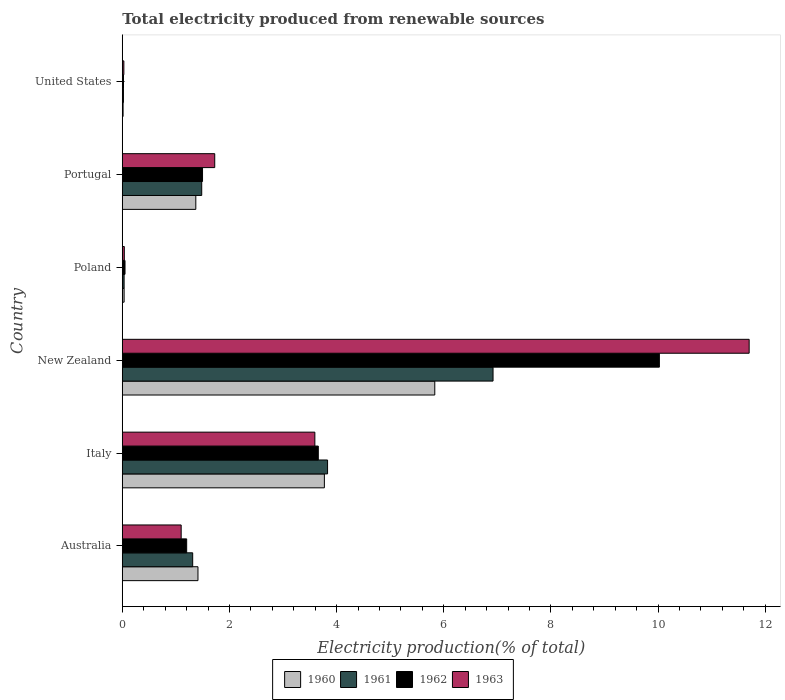How many different coloured bars are there?
Provide a succinct answer. 4. How many groups of bars are there?
Your answer should be very brief. 6. Are the number of bars per tick equal to the number of legend labels?
Provide a short and direct response. Yes. Are the number of bars on each tick of the Y-axis equal?
Give a very brief answer. Yes. How many bars are there on the 1st tick from the bottom?
Give a very brief answer. 4. What is the label of the 5th group of bars from the top?
Offer a very short reply. Italy. In how many cases, is the number of bars for a given country not equal to the number of legend labels?
Make the answer very short. 0. What is the total electricity produced in 1960 in Australia?
Make the answer very short. 1.41. Across all countries, what is the maximum total electricity produced in 1962?
Provide a short and direct response. 10.02. Across all countries, what is the minimum total electricity produced in 1960?
Provide a succinct answer. 0.02. In which country was the total electricity produced in 1963 maximum?
Provide a succinct answer. New Zealand. What is the total total electricity produced in 1961 in the graph?
Make the answer very short. 13.6. What is the difference between the total electricity produced in 1963 in Italy and that in Poland?
Make the answer very short. 3.56. What is the difference between the total electricity produced in 1961 in Australia and the total electricity produced in 1963 in Portugal?
Your answer should be compact. -0.41. What is the average total electricity produced in 1962 per country?
Ensure brevity in your answer.  2.74. What is the difference between the total electricity produced in 1963 and total electricity produced in 1962 in New Zealand?
Make the answer very short. 1.68. What is the ratio of the total electricity produced in 1961 in Portugal to that in United States?
Your answer should be compact. 68.83. What is the difference between the highest and the second highest total electricity produced in 1960?
Give a very brief answer. 2.06. What is the difference between the highest and the lowest total electricity produced in 1963?
Your answer should be very brief. 11.67. In how many countries, is the total electricity produced in 1962 greater than the average total electricity produced in 1962 taken over all countries?
Offer a terse response. 2. Is the sum of the total electricity produced in 1961 in Italy and United States greater than the maximum total electricity produced in 1962 across all countries?
Offer a terse response. No. Is it the case that in every country, the sum of the total electricity produced in 1961 and total electricity produced in 1962 is greater than the sum of total electricity produced in 1960 and total electricity produced in 1963?
Make the answer very short. No. How many bars are there?
Provide a succinct answer. 24. Are all the bars in the graph horizontal?
Provide a short and direct response. Yes. How many countries are there in the graph?
Ensure brevity in your answer.  6. What is the difference between two consecutive major ticks on the X-axis?
Your response must be concise. 2. Are the values on the major ticks of X-axis written in scientific E-notation?
Give a very brief answer. No. Does the graph contain any zero values?
Make the answer very short. No. Where does the legend appear in the graph?
Your answer should be very brief. Bottom center. How are the legend labels stacked?
Your response must be concise. Horizontal. What is the title of the graph?
Your answer should be very brief. Total electricity produced from renewable sources. What is the label or title of the X-axis?
Your answer should be very brief. Electricity production(% of total). What is the Electricity production(% of total) in 1960 in Australia?
Your answer should be very brief. 1.41. What is the Electricity production(% of total) of 1961 in Australia?
Your answer should be compact. 1.31. What is the Electricity production(% of total) of 1962 in Australia?
Keep it short and to the point. 1.2. What is the Electricity production(% of total) of 1963 in Australia?
Your response must be concise. 1.1. What is the Electricity production(% of total) in 1960 in Italy?
Keep it short and to the point. 3.77. What is the Electricity production(% of total) of 1961 in Italy?
Your answer should be very brief. 3.83. What is the Electricity production(% of total) of 1962 in Italy?
Your answer should be compact. 3.66. What is the Electricity production(% of total) of 1963 in Italy?
Ensure brevity in your answer.  3.59. What is the Electricity production(% of total) of 1960 in New Zealand?
Your answer should be very brief. 5.83. What is the Electricity production(% of total) of 1961 in New Zealand?
Offer a terse response. 6.92. What is the Electricity production(% of total) of 1962 in New Zealand?
Keep it short and to the point. 10.02. What is the Electricity production(% of total) of 1963 in New Zealand?
Make the answer very short. 11.7. What is the Electricity production(% of total) of 1960 in Poland?
Your response must be concise. 0.03. What is the Electricity production(% of total) of 1961 in Poland?
Offer a terse response. 0.03. What is the Electricity production(% of total) of 1962 in Poland?
Make the answer very short. 0.05. What is the Electricity production(% of total) in 1963 in Poland?
Give a very brief answer. 0.04. What is the Electricity production(% of total) in 1960 in Portugal?
Your response must be concise. 1.37. What is the Electricity production(% of total) in 1961 in Portugal?
Your answer should be compact. 1.48. What is the Electricity production(% of total) of 1962 in Portugal?
Provide a succinct answer. 1.5. What is the Electricity production(% of total) of 1963 in Portugal?
Provide a succinct answer. 1.73. What is the Electricity production(% of total) in 1960 in United States?
Give a very brief answer. 0.02. What is the Electricity production(% of total) of 1961 in United States?
Keep it short and to the point. 0.02. What is the Electricity production(% of total) of 1962 in United States?
Your response must be concise. 0.02. What is the Electricity production(% of total) in 1963 in United States?
Your answer should be compact. 0.03. Across all countries, what is the maximum Electricity production(% of total) in 1960?
Ensure brevity in your answer.  5.83. Across all countries, what is the maximum Electricity production(% of total) in 1961?
Your response must be concise. 6.92. Across all countries, what is the maximum Electricity production(% of total) of 1962?
Provide a short and direct response. 10.02. Across all countries, what is the maximum Electricity production(% of total) in 1963?
Your answer should be very brief. 11.7. Across all countries, what is the minimum Electricity production(% of total) of 1960?
Give a very brief answer. 0.02. Across all countries, what is the minimum Electricity production(% of total) in 1961?
Keep it short and to the point. 0.02. Across all countries, what is the minimum Electricity production(% of total) of 1962?
Ensure brevity in your answer.  0.02. Across all countries, what is the minimum Electricity production(% of total) of 1963?
Provide a short and direct response. 0.03. What is the total Electricity production(% of total) in 1960 in the graph?
Provide a short and direct response. 12.44. What is the total Electricity production(% of total) in 1961 in the graph?
Ensure brevity in your answer.  13.6. What is the total Electricity production(% of total) in 1962 in the graph?
Your answer should be compact. 16.46. What is the total Electricity production(% of total) in 1963 in the graph?
Your response must be concise. 18.19. What is the difference between the Electricity production(% of total) of 1960 in Australia and that in Italy?
Your answer should be very brief. -2.36. What is the difference between the Electricity production(% of total) of 1961 in Australia and that in Italy?
Your answer should be compact. -2.52. What is the difference between the Electricity production(% of total) of 1962 in Australia and that in Italy?
Your answer should be very brief. -2.46. What is the difference between the Electricity production(% of total) in 1963 in Australia and that in Italy?
Keep it short and to the point. -2.5. What is the difference between the Electricity production(% of total) in 1960 in Australia and that in New Zealand?
Your response must be concise. -4.42. What is the difference between the Electricity production(% of total) in 1961 in Australia and that in New Zealand?
Your response must be concise. -5.61. What is the difference between the Electricity production(% of total) in 1962 in Australia and that in New Zealand?
Provide a succinct answer. -8.82. What is the difference between the Electricity production(% of total) of 1963 in Australia and that in New Zealand?
Your response must be concise. -10.6. What is the difference between the Electricity production(% of total) in 1960 in Australia and that in Poland?
Your answer should be very brief. 1.38. What is the difference between the Electricity production(% of total) in 1961 in Australia and that in Poland?
Your answer should be very brief. 1.28. What is the difference between the Electricity production(% of total) of 1962 in Australia and that in Poland?
Keep it short and to the point. 1.15. What is the difference between the Electricity production(% of total) in 1963 in Australia and that in Poland?
Ensure brevity in your answer.  1.06. What is the difference between the Electricity production(% of total) in 1960 in Australia and that in Portugal?
Your response must be concise. 0.04. What is the difference between the Electricity production(% of total) in 1961 in Australia and that in Portugal?
Your answer should be very brief. -0.17. What is the difference between the Electricity production(% of total) in 1962 in Australia and that in Portugal?
Give a very brief answer. -0.3. What is the difference between the Electricity production(% of total) in 1963 in Australia and that in Portugal?
Your answer should be very brief. -0.63. What is the difference between the Electricity production(% of total) of 1960 in Australia and that in United States?
Keep it short and to the point. 1.4. What is the difference between the Electricity production(% of total) of 1961 in Australia and that in United States?
Provide a short and direct response. 1.29. What is the difference between the Electricity production(% of total) of 1962 in Australia and that in United States?
Make the answer very short. 1.18. What is the difference between the Electricity production(% of total) in 1963 in Australia and that in United States?
Make the answer very short. 1.07. What is the difference between the Electricity production(% of total) of 1960 in Italy and that in New Zealand?
Make the answer very short. -2.06. What is the difference between the Electricity production(% of total) of 1961 in Italy and that in New Zealand?
Make the answer very short. -3.09. What is the difference between the Electricity production(% of total) of 1962 in Italy and that in New Zealand?
Ensure brevity in your answer.  -6.37. What is the difference between the Electricity production(% of total) in 1963 in Italy and that in New Zealand?
Your answer should be very brief. -8.11. What is the difference between the Electricity production(% of total) in 1960 in Italy and that in Poland?
Make the answer very short. 3.74. What is the difference between the Electricity production(% of total) in 1961 in Italy and that in Poland?
Your answer should be very brief. 3.8. What is the difference between the Electricity production(% of total) of 1962 in Italy and that in Poland?
Offer a very short reply. 3.61. What is the difference between the Electricity production(% of total) in 1963 in Italy and that in Poland?
Give a very brief answer. 3.56. What is the difference between the Electricity production(% of total) in 1960 in Italy and that in Portugal?
Provide a succinct answer. 2.4. What is the difference between the Electricity production(% of total) of 1961 in Italy and that in Portugal?
Your answer should be very brief. 2.35. What is the difference between the Electricity production(% of total) in 1962 in Italy and that in Portugal?
Your response must be concise. 2.16. What is the difference between the Electricity production(% of total) of 1963 in Italy and that in Portugal?
Provide a succinct answer. 1.87. What is the difference between the Electricity production(% of total) in 1960 in Italy and that in United States?
Your answer should be very brief. 3.76. What is the difference between the Electricity production(% of total) of 1961 in Italy and that in United States?
Provide a succinct answer. 3.81. What is the difference between the Electricity production(% of total) in 1962 in Italy and that in United States?
Keep it short and to the point. 3.64. What is the difference between the Electricity production(% of total) in 1963 in Italy and that in United States?
Your answer should be compact. 3.56. What is the difference between the Electricity production(% of total) of 1960 in New Zealand and that in Poland?
Offer a terse response. 5.8. What is the difference between the Electricity production(% of total) of 1961 in New Zealand and that in Poland?
Your answer should be compact. 6.89. What is the difference between the Electricity production(% of total) in 1962 in New Zealand and that in Poland?
Offer a terse response. 9.97. What is the difference between the Electricity production(% of total) in 1963 in New Zealand and that in Poland?
Offer a very short reply. 11.66. What is the difference between the Electricity production(% of total) in 1960 in New Zealand and that in Portugal?
Provide a short and direct response. 4.46. What is the difference between the Electricity production(% of total) of 1961 in New Zealand and that in Portugal?
Keep it short and to the point. 5.44. What is the difference between the Electricity production(% of total) in 1962 in New Zealand and that in Portugal?
Your answer should be very brief. 8.53. What is the difference between the Electricity production(% of total) of 1963 in New Zealand and that in Portugal?
Your answer should be compact. 9.97. What is the difference between the Electricity production(% of total) in 1960 in New Zealand and that in United States?
Make the answer very short. 5.82. What is the difference between the Electricity production(% of total) in 1961 in New Zealand and that in United States?
Make the answer very short. 6.9. What is the difference between the Electricity production(% of total) of 1962 in New Zealand and that in United States?
Make the answer very short. 10. What is the difference between the Electricity production(% of total) in 1963 in New Zealand and that in United States?
Your response must be concise. 11.67. What is the difference between the Electricity production(% of total) of 1960 in Poland and that in Portugal?
Provide a succinct answer. -1.34. What is the difference between the Electricity production(% of total) of 1961 in Poland and that in Portugal?
Your answer should be compact. -1.45. What is the difference between the Electricity production(% of total) of 1962 in Poland and that in Portugal?
Provide a short and direct response. -1.45. What is the difference between the Electricity production(% of total) of 1963 in Poland and that in Portugal?
Offer a very short reply. -1.69. What is the difference between the Electricity production(% of total) of 1960 in Poland and that in United States?
Make the answer very short. 0.02. What is the difference between the Electricity production(% of total) in 1961 in Poland and that in United States?
Your answer should be very brief. 0.01. What is the difference between the Electricity production(% of total) of 1962 in Poland and that in United States?
Keep it short and to the point. 0.03. What is the difference between the Electricity production(% of total) in 1963 in Poland and that in United States?
Offer a very short reply. 0.01. What is the difference between the Electricity production(% of total) in 1960 in Portugal and that in United States?
Your answer should be compact. 1.36. What is the difference between the Electricity production(% of total) of 1961 in Portugal and that in United States?
Your answer should be compact. 1.46. What is the difference between the Electricity production(% of total) in 1962 in Portugal and that in United States?
Your response must be concise. 1.48. What is the difference between the Electricity production(% of total) in 1963 in Portugal and that in United States?
Your answer should be compact. 1.7. What is the difference between the Electricity production(% of total) in 1960 in Australia and the Electricity production(% of total) in 1961 in Italy?
Offer a very short reply. -2.42. What is the difference between the Electricity production(% of total) of 1960 in Australia and the Electricity production(% of total) of 1962 in Italy?
Make the answer very short. -2.25. What is the difference between the Electricity production(% of total) in 1960 in Australia and the Electricity production(% of total) in 1963 in Italy?
Keep it short and to the point. -2.18. What is the difference between the Electricity production(% of total) in 1961 in Australia and the Electricity production(% of total) in 1962 in Italy?
Keep it short and to the point. -2.34. What is the difference between the Electricity production(% of total) of 1961 in Australia and the Electricity production(% of total) of 1963 in Italy?
Provide a succinct answer. -2.28. What is the difference between the Electricity production(% of total) of 1962 in Australia and the Electricity production(% of total) of 1963 in Italy?
Make the answer very short. -2.39. What is the difference between the Electricity production(% of total) in 1960 in Australia and the Electricity production(% of total) in 1961 in New Zealand?
Keep it short and to the point. -5.51. What is the difference between the Electricity production(% of total) in 1960 in Australia and the Electricity production(% of total) in 1962 in New Zealand?
Offer a terse response. -8.61. What is the difference between the Electricity production(% of total) in 1960 in Australia and the Electricity production(% of total) in 1963 in New Zealand?
Make the answer very short. -10.29. What is the difference between the Electricity production(% of total) in 1961 in Australia and the Electricity production(% of total) in 1962 in New Zealand?
Your response must be concise. -8.71. What is the difference between the Electricity production(% of total) of 1961 in Australia and the Electricity production(% of total) of 1963 in New Zealand?
Provide a short and direct response. -10.39. What is the difference between the Electricity production(% of total) of 1962 in Australia and the Electricity production(% of total) of 1963 in New Zealand?
Keep it short and to the point. -10.5. What is the difference between the Electricity production(% of total) in 1960 in Australia and the Electricity production(% of total) in 1961 in Poland?
Keep it short and to the point. 1.38. What is the difference between the Electricity production(% of total) of 1960 in Australia and the Electricity production(% of total) of 1962 in Poland?
Keep it short and to the point. 1.36. What is the difference between the Electricity production(% of total) of 1960 in Australia and the Electricity production(% of total) of 1963 in Poland?
Give a very brief answer. 1.37. What is the difference between the Electricity production(% of total) of 1961 in Australia and the Electricity production(% of total) of 1962 in Poland?
Provide a succinct answer. 1.26. What is the difference between the Electricity production(% of total) of 1961 in Australia and the Electricity production(% of total) of 1963 in Poland?
Ensure brevity in your answer.  1.28. What is the difference between the Electricity production(% of total) in 1962 in Australia and the Electricity production(% of total) in 1963 in Poland?
Make the answer very short. 1.16. What is the difference between the Electricity production(% of total) of 1960 in Australia and the Electricity production(% of total) of 1961 in Portugal?
Your answer should be very brief. -0.07. What is the difference between the Electricity production(% of total) in 1960 in Australia and the Electricity production(% of total) in 1962 in Portugal?
Your response must be concise. -0.09. What is the difference between the Electricity production(% of total) in 1960 in Australia and the Electricity production(% of total) in 1963 in Portugal?
Give a very brief answer. -0.31. What is the difference between the Electricity production(% of total) in 1961 in Australia and the Electricity production(% of total) in 1962 in Portugal?
Give a very brief answer. -0.18. What is the difference between the Electricity production(% of total) of 1961 in Australia and the Electricity production(% of total) of 1963 in Portugal?
Your answer should be compact. -0.41. What is the difference between the Electricity production(% of total) in 1962 in Australia and the Electricity production(% of total) in 1963 in Portugal?
Give a very brief answer. -0.52. What is the difference between the Electricity production(% of total) in 1960 in Australia and the Electricity production(% of total) in 1961 in United States?
Give a very brief answer. 1.39. What is the difference between the Electricity production(% of total) in 1960 in Australia and the Electricity production(% of total) in 1962 in United States?
Your response must be concise. 1.39. What is the difference between the Electricity production(% of total) of 1960 in Australia and the Electricity production(% of total) of 1963 in United States?
Offer a very short reply. 1.38. What is the difference between the Electricity production(% of total) in 1961 in Australia and the Electricity production(% of total) in 1962 in United States?
Offer a terse response. 1.29. What is the difference between the Electricity production(% of total) in 1961 in Australia and the Electricity production(% of total) in 1963 in United States?
Make the answer very short. 1.28. What is the difference between the Electricity production(% of total) of 1962 in Australia and the Electricity production(% of total) of 1963 in United States?
Make the answer very short. 1.17. What is the difference between the Electricity production(% of total) in 1960 in Italy and the Electricity production(% of total) in 1961 in New Zealand?
Make the answer very short. -3.15. What is the difference between the Electricity production(% of total) in 1960 in Italy and the Electricity production(% of total) in 1962 in New Zealand?
Offer a terse response. -6.25. What is the difference between the Electricity production(% of total) of 1960 in Italy and the Electricity production(% of total) of 1963 in New Zealand?
Give a very brief answer. -7.93. What is the difference between the Electricity production(% of total) of 1961 in Italy and the Electricity production(% of total) of 1962 in New Zealand?
Provide a succinct answer. -6.19. What is the difference between the Electricity production(% of total) in 1961 in Italy and the Electricity production(% of total) in 1963 in New Zealand?
Make the answer very short. -7.87. What is the difference between the Electricity production(% of total) of 1962 in Italy and the Electricity production(% of total) of 1963 in New Zealand?
Keep it short and to the point. -8.04. What is the difference between the Electricity production(% of total) of 1960 in Italy and the Electricity production(% of total) of 1961 in Poland?
Make the answer very short. 3.74. What is the difference between the Electricity production(% of total) of 1960 in Italy and the Electricity production(% of total) of 1962 in Poland?
Ensure brevity in your answer.  3.72. What is the difference between the Electricity production(% of total) in 1960 in Italy and the Electricity production(% of total) in 1963 in Poland?
Provide a short and direct response. 3.73. What is the difference between the Electricity production(% of total) in 1961 in Italy and the Electricity production(% of total) in 1962 in Poland?
Your answer should be compact. 3.78. What is the difference between the Electricity production(% of total) in 1961 in Italy and the Electricity production(% of total) in 1963 in Poland?
Provide a succinct answer. 3.79. What is the difference between the Electricity production(% of total) of 1962 in Italy and the Electricity production(% of total) of 1963 in Poland?
Keep it short and to the point. 3.62. What is the difference between the Electricity production(% of total) of 1960 in Italy and the Electricity production(% of total) of 1961 in Portugal?
Provide a succinct answer. 2.29. What is the difference between the Electricity production(% of total) in 1960 in Italy and the Electricity production(% of total) in 1962 in Portugal?
Your answer should be compact. 2.27. What is the difference between the Electricity production(% of total) of 1960 in Italy and the Electricity production(% of total) of 1963 in Portugal?
Provide a succinct answer. 2.05. What is the difference between the Electricity production(% of total) in 1961 in Italy and the Electricity production(% of total) in 1962 in Portugal?
Give a very brief answer. 2.33. What is the difference between the Electricity production(% of total) in 1961 in Italy and the Electricity production(% of total) in 1963 in Portugal?
Provide a short and direct response. 2.11. What is the difference between the Electricity production(% of total) of 1962 in Italy and the Electricity production(% of total) of 1963 in Portugal?
Give a very brief answer. 1.93. What is the difference between the Electricity production(% of total) in 1960 in Italy and the Electricity production(% of total) in 1961 in United States?
Ensure brevity in your answer.  3.75. What is the difference between the Electricity production(% of total) in 1960 in Italy and the Electricity production(% of total) in 1962 in United States?
Offer a very short reply. 3.75. What is the difference between the Electricity production(% of total) in 1960 in Italy and the Electricity production(% of total) in 1963 in United States?
Ensure brevity in your answer.  3.74. What is the difference between the Electricity production(% of total) of 1961 in Italy and the Electricity production(% of total) of 1962 in United States?
Your answer should be very brief. 3.81. What is the difference between the Electricity production(% of total) of 1961 in Italy and the Electricity production(% of total) of 1963 in United States?
Provide a short and direct response. 3.8. What is the difference between the Electricity production(% of total) of 1962 in Italy and the Electricity production(% of total) of 1963 in United States?
Your answer should be compact. 3.63. What is the difference between the Electricity production(% of total) in 1960 in New Zealand and the Electricity production(% of total) in 1961 in Poland?
Offer a terse response. 5.8. What is the difference between the Electricity production(% of total) in 1960 in New Zealand and the Electricity production(% of total) in 1962 in Poland?
Offer a terse response. 5.78. What is the difference between the Electricity production(% of total) in 1960 in New Zealand and the Electricity production(% of total) in 1963 in Poland?
Ensure brevity in your answer.  5.79. What is the difference between the Electricity production(% of total) of 1961 in New Zealand and the Electricity production(% of total) of 1962 in Poland?
Provide a succinct answer. 6.87. What is the difference between the Electricity production(% of total) of 1961 in New Zealand and the Electricity production(% of total) of 1963 in Poland?
Provide a succinct answer. 6.88. What is the difference between the Electricity production(% of total) of 1962 in New Zealand and the Electricity production(% of total) of 1963 in Poland?
Offer a terse response. 9.99. What is the difference between the Electricity production(% of total) in 1960 in New Zealand and the Electricity production(% of total) in 1961 in Portugal?
Ensure brevity in your answer.  4.35. What is the difference between the Electricity production(% of total) in 1960 in New Zealand and the Electricity production(% of total) in 1962 in Portugal?
Keep it short and to the point. 4.33. What is the difference between the Electricity production(% of total) in 1960 in New Zealand and the Electricity production(% of total) in 1963 in Portugal?
Offer a very short reply. 4.11. What is the difference between the Electricity production(% of total) in 1961 in New Zealand and the Electricity production(% of total) in 1962 in Portugal?
Ensure brevity in your answer.  5.42. What is the difference between the Electricity production(% of total) in 1961 in New Zealand and the Electricity production(% of total) in 1963 in Portugal?
Your answer should be very brief. 5.19. What is the difference between the Electricity production(% of total) in 1962 in New Zealand and the Electricity production(% of total) in 1963 in Portugal?
Offer a terse response. 8.3. What is the difference between the Electricity production(% of total) in 1960 in New Zealand and the Electricity production(% of total) in 1961 in United States?
Your answer should be very brief. 5.81. What is the difference between the Electricity production(% of total) of 1960 in New Zealand and the Electricity production(% of total) of 1962 in United States?
Offer a terse response. 5.81. What is the difference between the Electricity production(% of total) in 1960 in New Zealand and the Electricity production(% of total) in 1963 in United States?
Provide a short and direct response. 5.8. What is the difference between the Electricity production(% of total) of 1961 in New Zealand and the Electricity production(% of total) of 1962 in United States?
Provide a succinct answer. 6.9. What is the difference between the Electricity production(% of total) of 1961 in New Zealand and the Electricity production(% of total) of 1963 in United States?
Offer a terse response. 6.89. What is the difference between the Electricity production(% of total) in 1962 in New Zealand and the Electricity production(% of total) in 1963 in United States?
Give a very brief answer. 10. What is the difference between the Electricity production(% of total) of 1960 in Poland and the Electricity production(% of total) of 1961 in Portugal?
Provide a succinct answer. -1.45. What is the difference between the Electricity production(% of total) in 1960 in Poland and the Electricity production(% of total) in 1962 in Portugal?
Provide a short and direct response. -1.46. What is the difference between the Electricity production(% of total) of 1960 in Poland and the Electricity production(% of total) of 1963 in Portugal?
Keep it short and to the point. -1.69. What is the difference between the Electricity production(% of total) of 1961 in Poland and the Electricity production(% of total) of 1962 in Portugal?
Your answer should be very brief. -1.46. What is the difference between the Electricity production(% of total) in 1961 in Poland and the Electricity production(% of total) in 1963 in Portugal?
Your answer should be compact. -1.69. What is the difference between the Electricity production(% of total) of 1962 in Poland and the Electricity production(% of total) of 1963 in Portugal?
Provide a succinct answer. -1.67. What is the difference between the Electricity production(% of total) in 1960 in Poland and the Electricity production(% of total) in 1961 in United States?
Give a very brief answer. 0.01. What is the difference between the Electricity production(% of total) of 1960 in Poland and the Electricity production(% of total) of 1962 in United States?
Offer a very short reply. 0.01. What is the difference between the Electricity production(% of total) in 1960 in Poland and the Electricity production(% of total) in 1963 in United States?
Offer a very short reply. 0. What is the difference between the Electricity production(% of total) in 1961 in Poland and the Electricity production(% of total) in 1962 in United States?
Your answer should be very brief. 0.01. What is the difference between the Electricity production(% of total) of 1961 in Poland and the Electricity production(% of total) of 1963 in United States?
Your response must be concise. 0. What is the difference between the Electricity production(% of total) in 1962 in Poland and the Electricity production(% of total) in 1963 in United States?
Keep it short and to the point. 0.02. What is the difference between the Electricity production(% of total) in 1960 in Portugal and the Electricity production(% of total) in 1961 in United States?
Offer a very short reply. 1.35. What is the difference between the Electricity production(% of total) in 1960 in Portugal and the Electricity production(% of total) in 1962 in United States?
Offer a very short reply. 1.35. What is the difference between the Electricity production(% of total) in 1960 in Portugal and the Electricity production(% of total) in 1963 in United States?
Make the answer very short. 1.34. What is the difference between the Electricity production(% of total) in 1961 in Portugal and the Electricity production(% of total) in 1962 in United States?
Keep it short and to the point. 1.46. What is the difference between the Electricity production(% of total) in 1961 in Portugal and the Electricity production(% of total) in 1963 in United States?
Your answer should be compact. 1.45. What is the difference between the Electricity production(% of total) in 1962 in Portugal and the Electricity production(% of total) in 1963 in United States?
Your response must be concise. 1.47. What is the average Electricity production(% of total) in 1960 per country?
Offer a very short reply. 2.07. What is the average Electricity production(% of total) of 1961 per country?
Make the answer very short. 2.27. What is the average Electricity production(% of total) in 1962 per country?
Your response must be concise. 2.74. What is the average Electricity production(% of total) in 1963 per country?
Offer a terse response. 3.03. What is the difference between the Electricity production(% of total) in 1960 and Electricity production(% of total) in 1961 in Australia?
Ensure brevity in your answer.  0.1. What is the difference between the Electricity production(% of total) in 1960 and Electricity production(% of total) in 1962 in Australia?
Keep it short and to the point. 0.21. What is the difference between the Electricity production(% of total) in 1960 and Electricity production(% of total) in 1963 in Australia?
Give a very brief answer. 0.31. What is the difference between the Electricity production(% of total) of 1961 and Electricity production(% of total) of 1962 in Australia?
Your answer should be compact. 0.11. What is the difference between the Electricity production(% of total) in 1961 and Electricity production(% of total) in 1963 in Australia?
Your answer should be very brief. 0.21. What is the difference between the Electricity production(% of total) in 1962 and Electricity production(% of total) in 1963 in Australia?
Keep it short and to the point. 0.1. What is the difference between the Electricity production(% of total) of 1960 and Electricity production(% of total) of 1961 in Italy?
Offer a terse response. -0.06. What is the difference between the Electricity production(% of total) of 1960 and Electricity production(% of total) of 1962 in Italy?
Your answer should be compact. 0.11. What is the difference between the Electricity production(% of total) of 1960 and Electricity production(% of total) of 1963 in Italy?
Ensure brevity in your answer.  0.18. What is the difference between the Electricity production(% of total) of 1961 and Electricity production(% of total) of 1962 in Italy?
Your answer should be very brief. 0.17. What is the difference between the Electricity production(% of total) in 1961 and Electricity production(% of total) in 1963 in Italy?
Provide a short and direct response. 0.24. What is the difference between the Electricity production(% of total) of 1962 and Electricity production(% of total) of 1963 in Italy?
Keep it short and to the point. 0.06. What is the difference between the Electricity production(% of total) in 1960 and Electricity production(% of total) in 1961 in New Zealand?
Provide a succinct answer. -1.09. What is the difference between the Electricity production(% of total) of 1960 and Electricity production(% of total) of 1962 in New Zealand?
Ensure brevity in your answer.  -4.19. What is the difference between the Electricity production(% of total) of 1960 and Electricity production(% of total) of 1963 in New Zealand?
Offer a very short reply. -5.87. What is the difference between the Electricity production(% of total) of 1961 and Electricity production(% of total) of 1962 in New Zealand?
Make the answer very short. -3.1. What is the difference between the Electricity production(% of total) in 1961 and Electricity production(% of total) in 1963 in New Zealand?
Offer a very short reply. -4.78. What is the difference between the Electricity production(% of total) of 1962 and Electricity production(% of total) of 1963 in New Zealand?
Keep it short and to the point. -1.68. What is the difference between the Electricity production(% of total) of 1960 and Electricity production(% of total) of 1961 in Poland?
Provide a succinct answer. 0. What is the difference between the Electricity production(% of total) in 1960 and Electricity production(% of total) in 1962 in Poland?
Your response must be concise. -0.02. What is the difference between the Electricity production(% of total) in 1960 and Electricity production(% of total) in 1963 in Poland?
Keep it short and to the point. -0. What is the difference between the Electricity production(% of total) of 1961 and Electricity production(% of total) of 1962 in Poland?
Provide a short and direct response. -0.02. What is the difference between the Electricity production(% of total) in 1961 and Electricity production(% of total) in 1963 in Poland?
Your response must be concise. -0. What is the difference between the Electricity production(% of total) in 1962 and Electricity production(% of total) in 1963 in Poland?
Ensure brevity in your answer.  0.01. What is the difference between the Electricity production(% of total) in 1960 and Electricity production(% of total) in 1961 in Portugal?
Give a very brief answer. -0.11. What is the difference between the Electricity production(% of total) in 1960 and Electricity production(% of total) in 1962 in Portugal?
Your answer should be very brief. -0.13. What is the difference between the Electricity production(% of total) of 1960 and Electricity production(% of total) of 1963 in Portugal?
Provide a succinct answer. -0.35. What is the difference between the Electricity production(% of total) of 1961 and Electricity production(% of total) of 1962 in Portugal?
Provide a succinct answer. -0.02. What is the difference between the Electricity production(% of total) in 1961 and Electricity production(% of total) in 1963 in Portugal?
Your answer should be very brief. -0.24. What is the difference between the Electricity production(% of total) of 1962 and Electricity production(% of total) of 1963 in Portugal?
Offer a very short reply. -0.23. What is the difference between the Electricity production(% of total) in 1960 and Electricity production(% of total) in 1961 in United States?
Ensure brevity in your answer.  -0.01. What is the difference between the Electricity production(% of total) of 1960 and Electricity production(% of total) of 1962 in United States?
Ensure brevity in your answer.  -0.01. What is the difference between the Electricity production(% of total) in 1960 and Electricity production(% of total) in 1963 in United States?
Make the answer very short. -0.01. What is the difference between the Electricity production(% of total) of 1961 and Electricity production(% of total) of 1962 in United States?
Your answer should be compact. -0. What is the difference between the Electricity production(% of total) of 1961 and Electricity production(% of total) of 1963 in United States?
Provide a short and direct response. -0.01. What is the difference between the Electricity production(% of total) of 1962 and Electricity production(% of total) of 1963 in United States?
Ensure brevity in your answer.  -0.01. What is the ratio of the Electricity production(% of total) of 1960 in Australia to that in Italy?
Keep it short and to the point. 0.37. What is the ratio of the Electricity production(% of total) of 1961 in Australia to that in Italy?
Give a very brief answer. 0.34. What is the ratio of the Electricity production(% of total) of 1962 in Australia to that in Italy?
Keep it short and to the point. 0.33. What is the ratio of the Electricity production(% of total) in 1963 in Australia to that in Italy?
Your answer should be compact. 0.31. What is the ratio of the Electricity production(% of total) in 1960 in Australia to that in New Zealand?
Make the answer very short. 0.24. What is the ratio of the Electricity production(% of total) in 1961 in Australia to that in New Zealand?
Ensure brevity in your answer.  0.19. What is the ratio of the Electricity production(% of total) in 1962 in Australia to that in New Zealand?
Offer a very short reply. 0.12. What is the ratio of the Electricity production(% of total) in 1963 in Australia to that in New Zealand?
Offer a very short reply. 0.09. What is the ratio of the Electricity production(% of total) in 1960 in Australia to that in Poland?
Ensure brevity in your answer.  41.37. What is the ratio of the Electricity production(% of total) of 1961 in Australia to that in Poland?
Keep it short and to the point. 38.51. What is the ratio of the Electricity production(% of total) in 1962 in Australia to that in Poland?
Your answer should be very brief. 23.61. What is the ratio of the Electricity production(% of total) in 1963 in Australia to that in Poland?
Offer a terse response. 29. What is the ratio of the Electricity production(% of total) of 1960 in Australia to that in Portugal?
Give a very brief answer. 1.03. What is the ratio of the Electricity production(% of total) in 1961 in Australia to that in Portugal?
Give a very brief answer. 0.89. What is the ratio of the Electricity production(% of total) of 1962 in Australia to that in Portugal?
Keep it short and to the point. 0.8. What is the ratio of the Electricity production(% of total) in 1963 in Australia to that in Portugal?
Give a very brief answer. 0.64. What is the ratio of the Electricity production(% of total) in 1960 in Australia to that in United States?
Offer a very short reply. 92.6. What is the ratio of the Electricity production(% of total) of 1961 in Australia to that in United States?
Offer a very short reply. 61. What is the ratio of the Electricity production(% of total) of 1962 in Australia to that in United States?
Provide a succinct answer. 52.74. What is the ratio of the Electricity production(% of total) in 1963 in Australia to that in United States?
Offer a very short reply. 37.34. What is the ratio of the Electricity production(% of total) in 1960 in Italy to that in New Zealand?
Your answer should be very brief. 0.65. What is the ratio of the Electricity production(% of total) of 1961 in Italy to that in New Zealand?
Provide a short and direct response. 0.55. What is the ratio of the Electricity production(% of total) of 1962 in Italy to that in New Zealand?
Give a very brief answer. 0.36. What is the ratio of the Electricity production(% of total) in 1963 in Italy to that in New Zealand?
Offer a very short reply. 0.31. What is the ratio of the Electricity production(% of total) in 1960 in Italy to that in Poland?
Provide a succinct answer. 110.45. What is the ratio of the Electricity production(% of total) of 1961 in Italy to that in Poland?
Ensure brevity in your answer.  112.3. What is the ratio of the Electricity production(% of total) of 1962 in Italy to that in Poland?
Provide a short and direct response. 71.88. What is the ratio of the Electricity production(% of total) of 1963 in Italy to that in Poland?
Provide a succinct answer. 94.84. What is the ratio of the Electricity production(% of total) in 1960 in Italy to that in Portugal?
Keep it short and to the point. 2.75. What is the ratio of the Electricity production(% of total) in 1961 in Italy to that in Portugal?
Keep it short and to the point. 2.58. What is the ratio of the Electricity production(% of total) of 1962 in Italy to that in Portugal?
Offer a terse response. 2.44. What is the ratio of the Electricity production(% of total) in 1963 in Italy to that in Portugal?
Your answer should be very brief. 2.08. What is the ratio of the Electricity production(% of total) of 1960 in Italy to that in United States?
Offer a very short reply. 247.25. What is the ratio of the Electricity production(% of total) in 1961 in Italy to that in United States?
Provide a short and direct response. 177.87. What is the ratio of the Electricity production(% of total) in 1962 in Italy to that in United States?
Your answer should be compact. 160.56. What is the ratio of the Electricity production(% of total) in 1963 in Italy to that in United States?
Give a very brief answer. 122.12. What is the ratio of the Electricity production(% of total) in 1960 in New Zealand to that in Poland?
Provide a short and direct response. 170.79. What is the ratio of the Electricity production(% of total) in 1961 in New Zealand to that in Poland?
Provide a succinct answer. 202.83. What is the ratio of the Electricity production(% of total) in 1962 in New Zealand to that in Poland?
Your answer should be compact. 196.95. What is the ratio of the Electricity production(% of total) of 1963 in New Zealand to that in Poland?
Offer a terse response. 308.73. What is the ratio of the Electricity production(% of total) in 1960 in New Zealand to that in Portugal?
Provide a succinct answer. 4.25. What is the ratio of the Electricity production(% of total) in 1961 in New Zealand to that in Portugal?
Make the answer very short. 4.67. What is the ratio of the Electricity production(% of total) of 1962 in New Zealand to that in Portugal?
Your response must be concise. 6.69. What is the ratio of the Electricity production(% of total) of 1963 in New Zealand to that in Portugal?
Your answer should be compact. 6.78. What is the ratio of the Electricity production(% of total) of 1960 in New Zealand to that in United States?
Keep it short and to the point. 382.31. What is the ratio of the Electricity production(% of total) of 1961 in New Zealand to that in United States?
Ensure brevity in your answer.  321.25. What is the ratio of the Electricity production(% of total) of 1962 in New Zealand to that in United States?
Provide a succinct answer. 439.93. What is the ratio of the Electricity production(% of total) of 1963 in New Zealand to that in United States?
Keep it short and to the point. 397.5. What is the ratio of the Electricity production(% of total) in 1960 in Poland to that in Portugal?
Your answer should be very brief. 0.02. What is the ratio of the Electricity production(% of total) of 1961 in Poland to that in Portugal?
Your response must be concise. 0.02. What is the ratio of the Electricity production(% of total) in 1962 in Poland to that in Portugal?
Provide a short and direct response. 0.03. What is the ratio of the Electricity production(% of total) in 1963 in Poland to that in Portugal?
Offer a terse response. 0.02. What is the ratio of the Electricity production(% of total) in 1960 in Poland to that in United States?
Keep it short and to the point. 2.24. What is the ratio of the Electricity production(% of total) in 1961 in Poland to that in United States?
Ensure brevity in your answer.  1.58. What is the ratio of the Electricity production(% of total) of 1962 in Poland to that in United States?
Offer a terse response. 2.23. What is the ratio of the Electricity production(% of total) of 1963 in Poland to that in United States?
Give a very brief answer. 1.29. What is the ratio of the Electricity production(% of total) of 1960 in Portugal to that in United States?
Keep it short and to the point. 89.96. What is the ratio of the Electricity production(% of total) in 1961 in Portugal to that in United States?
Make the answer very short. 68.83. What is the ratio of the Electricity production(% of total) in 1962 in Portugal to that in United States?
Give a very brief answer. 65.74. What is the ratio of the Electricity production(% of total) of 1963 in Portugal to that in United States?
Provide a short and direct response. 58.63. What is the difference between the highest and the second highest Electricity production(% of total) of 1960?
Ensure brevity in your answer.  2.06. What is the difference between the highest and the second highest Electricity production(% of total) in 1961?
Your answer should be very brief. 3.09. What is the difference between the highest and the second highest Electricity production(% of total) in 1962?
Provide a short and direct response. 6.37. What is the difference between the highest and the second highest Electricity production(% of total) in 1963?
Offer a very short reply. 8.11. What is the difference between the highest and the lowest Electricity production(% of total) of 1960?
Ensure brevity in your answer.  5.82. What is the difference between the highest and the lowest Electricity production(% of total) of 1961?
Give a very brief answer. 6.9. What is the difference between the highest and the lowest Electricity production(% of total) of 1962?
Give a very brief answer. 10. What is the difference between the highest and the lowest Electricity production(% of total) of 1963?
Offer a terse response. 11.67. 